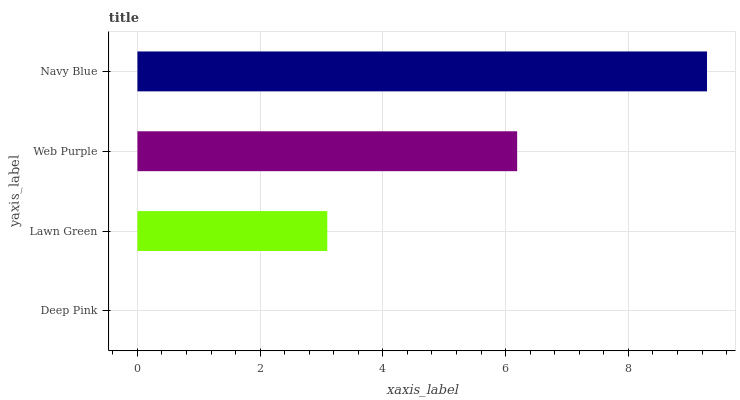Is Deep Pink the minimum?
Answer yes or no. Yes. Is Navy Blue the maximum?
Answer yes or no. Yes. Is Lawn Green the minimum?
Answer yes or no. No. Is Lawn Green the maximum?
Answer yes or no. No. Is Lawn Green greater than Deep Pink?
Answer yes or no. Yes. Is Deep Pink less than Lawn Green?
Answer yes or no. Yes. Is Deep Pink greater than Lawn Green?
Answer yes or no. No. Is Lawn Green less than Deep Pink?
Answer yes or no. No. Is Web Purple the high median?
Answer yes or no. Yes. Is Lawn Green the low median?
Answer yes or no. Yes. Is Deep Pink the high median?
Answer yes or no. No. Is Deep Pink the low median?
Answer yes or no. No. 